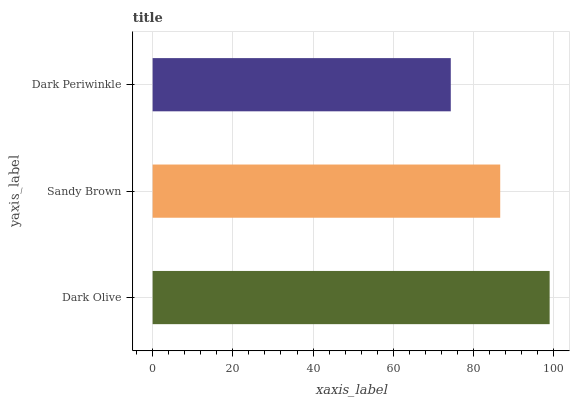Is Dark Periwinkle the minimum?
Answer yes or no. Yes. Is Dark Olive the maximum?
Answer yes or no. Yes. Is Sandy Brown the minimum?
Answer yes or no. No. Is Sandy Brown the maximum?
Answer yes or no. No. Is Dark Olive greater than Sandy Brown?
Answer yes or no. Yes. Is Sandy Brown less than Dark Olive?
Answer yes or no. Yes. Is Sandy Brown greater than Dark Olive?
Answer yes or no. No. Is Dark Olive less than Sandy Brown?
Answer yes or no. No. Is Sandy Brown the high median?
Answer yes or no. Yes. Is Sandy Brown the low median?
Answer yes or no. Yes. Is Dark Olive the high median?
Answer yes or no. No. Is Dark Olive the low median?
Answer yes or no. No. 